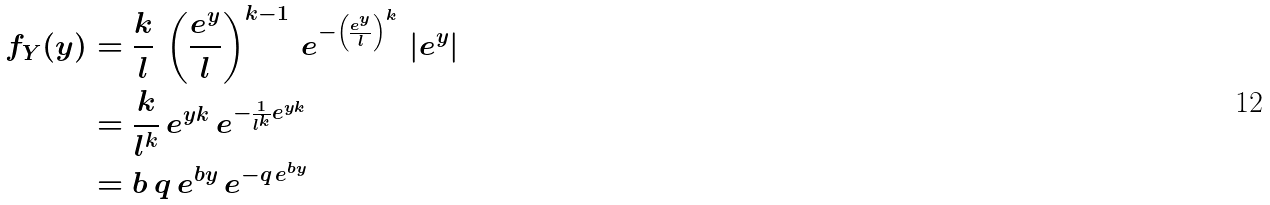Convert formula to latex. <formula><loc_0><loc_0><loc_500><loc_500>f _ { Y } ( y ) & = \frac { k } { l } \, \left ( \frac { e ^ { y } } { l } \right ) ^ { k - 1 } \, e ^ { - \left ( \frac { e ^ { y } } { l } \right ) ^ { k } } \, \left | e ^ { y } \right | \\ & = \frac { k } { l ^ { k } } \, e ^ { y k } \, e ^ { - \frac { 1 } { l ^ { k } } e ^ { y k } } \\ & = b \, q \, e ^ { b y } \, e ^ { - q \, e ^ { b y } }</formula> 